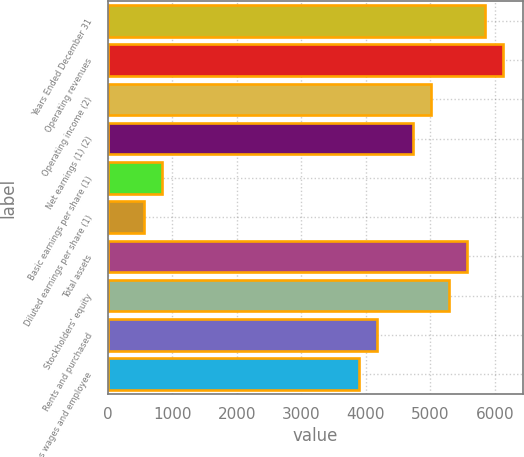Convert chart to OTSL. <chart><loc_0><loc_0><loc_500><loc_500><bar_chart><fcel>Years Ended December 31<fcel>Operating revenues<fcel>Operating income (2)<fcel>Net earnings (1) (2)<fcel>Basic earnings per share (1)<fcel>Diluted earnings per share (1)<fcel>Total assets<fcel>Stockholders' equity<fcel>Rents and purchased<fcel>Salaries wages and employee<nl><fcel>5850.27<fcel>6128.84<fcel>5014.56<fcel>4735.99<fcel>836.01<fcel>557.44<fcel>5571.7<fcel>5293.13<fcel>4178.85<fcel>3900.28<nl></chart> 